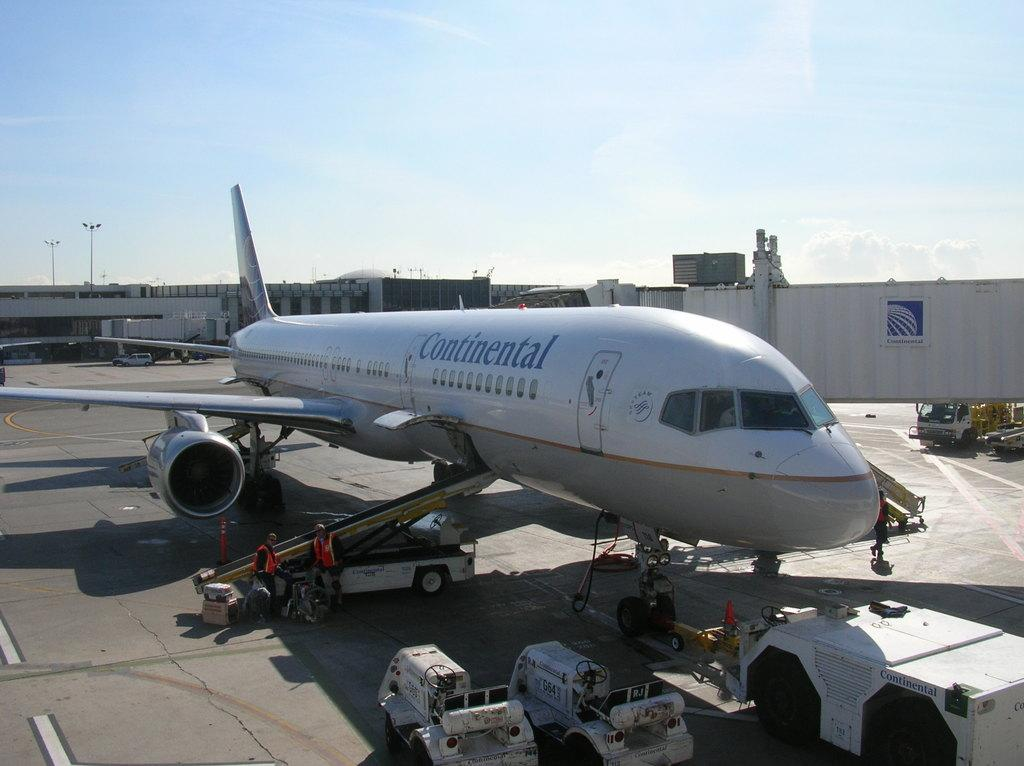<image>
Present a compact description of the photo's key features. A large white Continental aeroplane on tarmac on a sunny day 